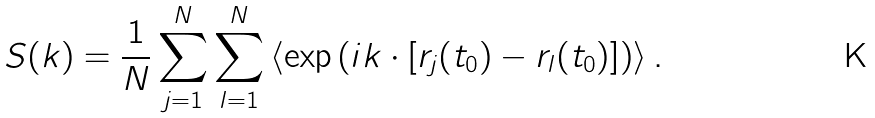Convert formula to latex. <formula><loc_0><loc_0><loc_500><loc_500>S ( k ) = \frac { 1 } { N } \sum _ { j = 1 } ^ { N } \sum _ { l = 1 } ^ { N } \left \langle \exp \left ( i k \cdot \left [ r _ { j } ( t _ { 0 } ) - r _ { l } ( t _ { 0 } ) \right ] \right ) \right \rangle .</formula> 